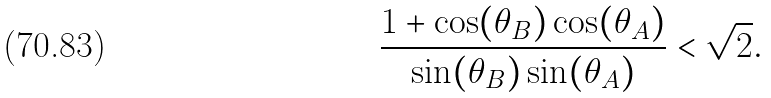Convert formula to latex. <formula><loc_0><loc_0><loc_500><loc_500>\frac { 1 + \cos ( \theta _ { B } ) \cos ( \theta _ { A } ) } { \sin ( \theta _ { B } ) \sin ( \theta _ { A } ) } < \sqrt { 2 } .</formula> 